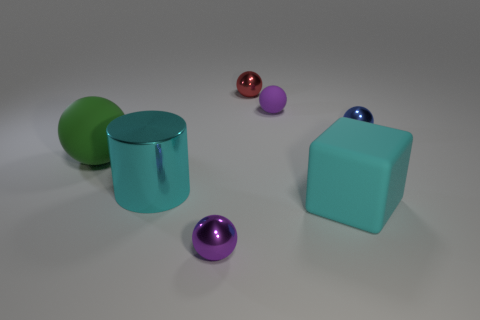Subtract all big spheres. How many spheres are left? 4 Add 3 small red things. How many objects exist? 10 Subtract 4 balls. How many balls are left? 1 Subtract all red balls. How many balls are left? 4 Subtract all blue cylinders. How many purple spheres are left? 2 Subtract all cylinders. How many objects are left? 6 Subtract all blue cylinders. Subtract all purple blocks. How many cylinders are left? 1 Subtract all big brown matte cylinders. Subtract all big green rubber spheres. How many objects are left? 6 Add 6 blue balls. How many blue balls are left? 7 Add 1 shiny cylinders. How many shiny cylinders exist? 2 